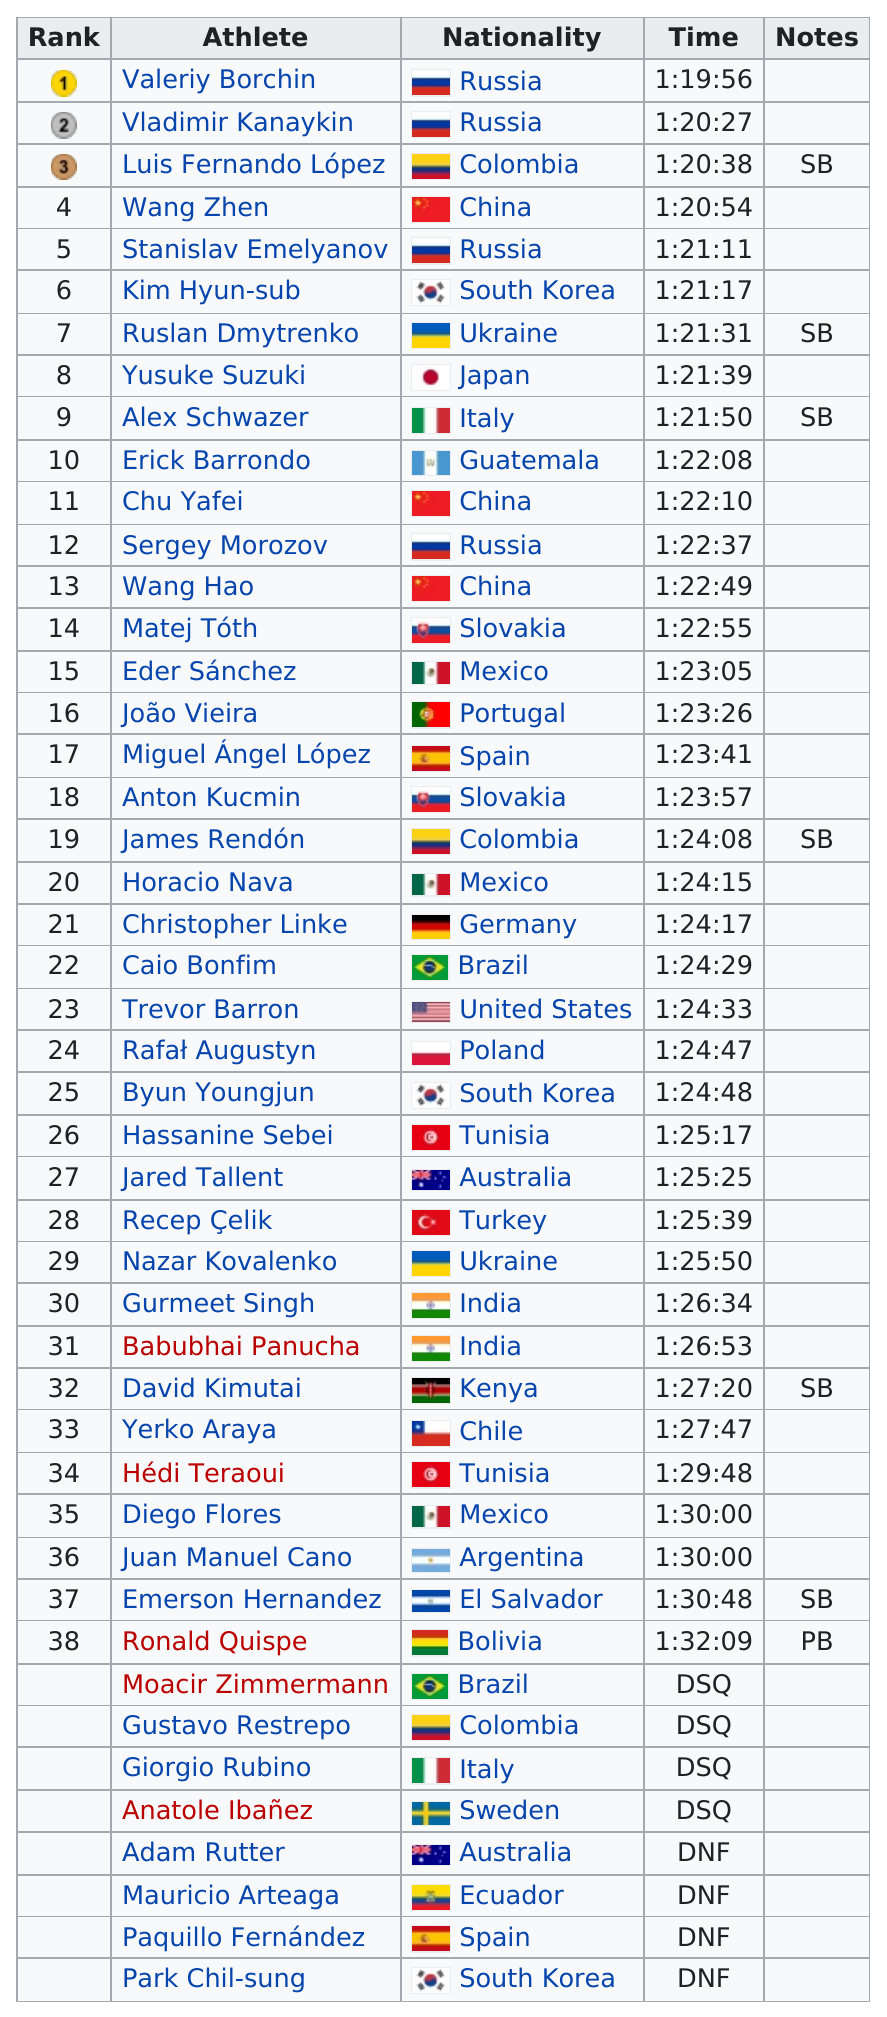Point out several critical features in this image. All athletes named were slower than Horacio Nava. Valeriy Borchin was ranked first among his competitors. The total number of athletes included in the rankings chart, including those classified as DSQ and DNF, is 46. According to the available data, two Russians have finished in the top three of the 20km walk event. Out of the total number of competitors, 4 were from Russia. 